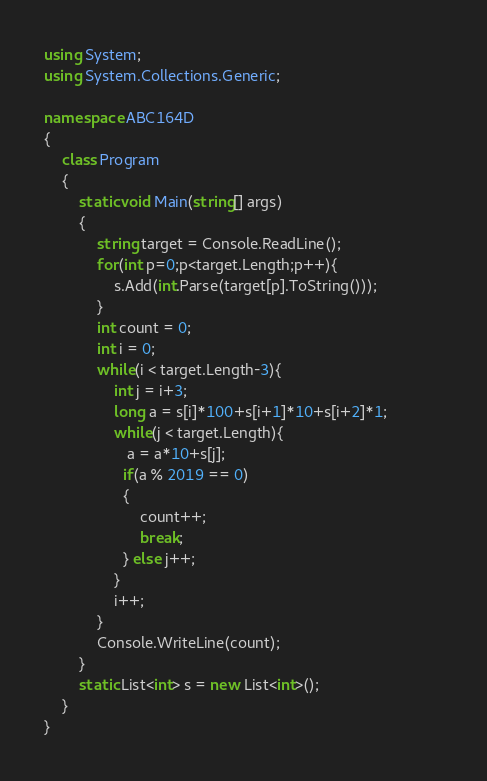<code> <loc_0><loc_0><loc_500><loc_500><_C#_>using System;
using System.Collections.Generic;

namespace ABC164D
{
    class Program
    {
        static void Main(string[] args)
        {
            string target = Console.ReadLine();
            for(int p=0;p<target.Length;p++){
                s.Add(int.Parse(target[p].ToString()));               
            }
            int count = 0;
            int i = 0;
            while(i < target.Length-3){
                int j = i+3;
                long a = s[i]*100+s[i+1]*10+s[i+2]*1;
                while(j < target.Length){
                   a = a*10+s[j];
                  if(a % 2019 == 0)
                  {
                      count++;
                      break;
                  } else j++;
                }
                i++;
            }
            Console.WriteLine(count);
        }
        static List<int> s = new List<int>();
    }
}
</code> 